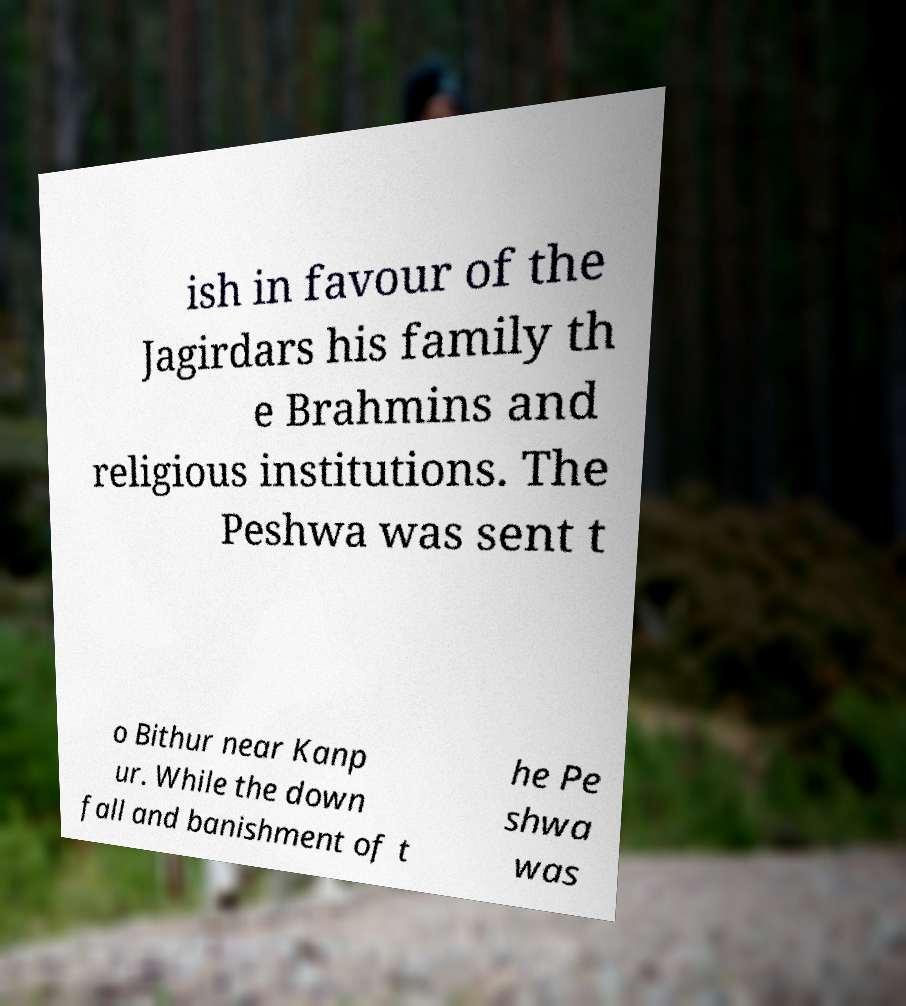Can you accurately transcribe the text from the provided image for me? ish in favour of the Jagirdars his family th e Brahmins and religious institutions. The Peshwa was sent t o Bithur near Kanp ur. While the down fall and banishment of t he Pe shwa was 